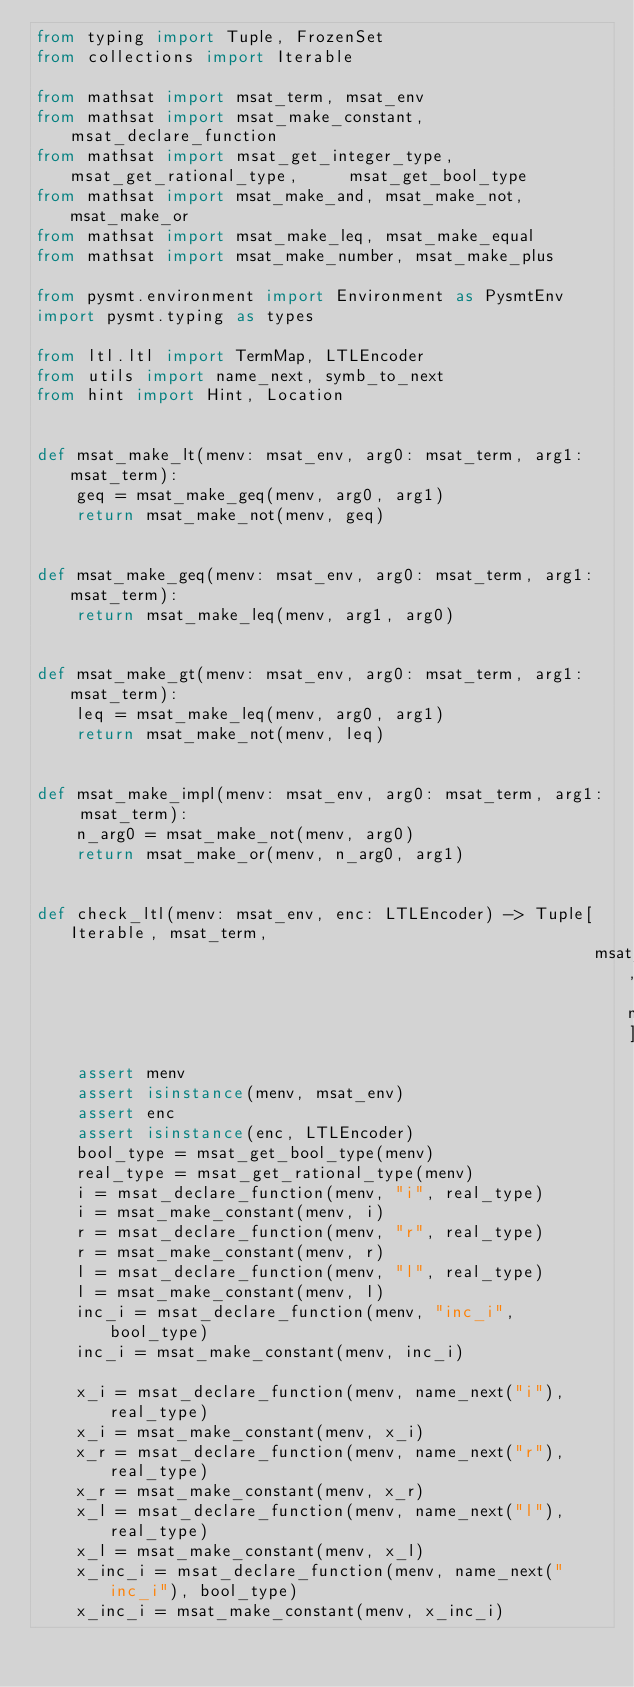Convert code to text. <code><loc_0><loc_0><loc_500><loc_500><_Python_>from typing import Tuple, FrozenSet
from collections import Iterable

from mathsat import msat_term, msat_env
from mathsat import msat_make_constant, msat_declare_function
from mathsat import msat_get_integer_type, msat_get_rational_type,     msat_get_bool_type
from mathsat import msat_make_and, msat_make_not, msat_make_or
from mathsat import msat_make_leq, msat_make_equal
from mathsat import msat_make_number, msat_make_plus

from pysmt.environment import Environment as PysmtEnv
import pysmt.typing as types

from ltl.ltl import TermMap, LTLEncoder
from utils import name_next, symb_to_next
from hint import Hint, Location


def msat_make_lt(menv: msat_env, arg0: msat_term, arg1: msat_term):
    geq = msat_make_geq(menv, arg0, arg1)
    return msat_make_not(menv, geq)


def msat_make_geq(menv: msat_env, arg0: msat_term, arg1: msat_term):
    return msat_make_leq(menv, arg1, arg0)


def msat_make_gt(menv: msat_env, arg0: msat_term, arg1: msat_term):
    leq = msat_make_leq(menv, arg0, arg1)
    return msat_make_not(menv, leq)


def msat_make_impl(menv: msat_env, arg0: msat_term, arg1: msat_term):
    n_arg0 = msat_make_not(menv, arg0)
    return msat_make_or(menv, n_arg0, arg1)


def check_ltl(menv: msat_env, enc: LTLEncoder) -> Tuple[Iterable, msat_term,
                                                        msat_term, msat_term]:
    assert menv
    assert isinstance(menv, msat_env)
    assert enc
    assert isinstance(enc, LTLEncoder)
    bool_type = msat_get_bool_type(menv)
    real_type = msat_get_rational_type(menv)
    i = msat_declare_function(menv, "i", real_type)
    i = msat_make_constant(menv, i)
    r = msat_declare_function(menv, "r", real_type)
    r = msat_make_constant(menv, r)
    l = msat_declare_function(menv, "l", real_type)
    l = msat_make_constant(menv, l)
    inc_i = msat_declare_function(menv, "inc_i", bool_type)
    inc_i = msat_make_constant(menv, inc_i)

    x_i = msat_declare_function(menv, name_next("i"), real_type)
    x_i = msat_make_constant(menv, x_i)
    x_r = msat_declare_function(menv, name_next("r"), real_type)
    x_r = msat_make_constant(menv, x_r)
    x_l = msat_declare_function(menv, name_next("l"), real_type)
    x_l = msat_make_constant(menv, x_l)
    x_inc_i = msat_declare_function(menv, name_next("inc_i"), bool_type)
    x_inc_i = msat_make_constant(menv, x_inc_i)
</code> 